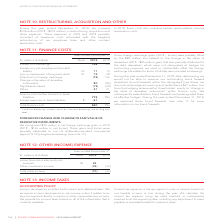According to Rogers Communications's financial document, What is included in the Interest on borrowings? Interest on borrowings includes interest on short-term borrowings and on long-term debt.. The document states: "1 Interest on borrowings includes interest on short-term borrowings and on long-term debt...." Also, What is attributed as change in fair value of derivatives? primarily attributed to the debt derivatives, which were not designated as hedges for accounting purposes, we used to substantially offset the foreign exchange risk related to these US dollar-denominated borrowings.. The document states: "of derivatives (2018 – $95 million gain) that was primarily attributed to the debt derivatives, which were not designated as hedges for accounting pur..." Also, How much was the net foreign exchange gains in 2019? $79 million in net foreign exchange gains in 2019. The document states: "FAIR VALUE OF DERIVATIVE INSTRUMENTS We recognized $79 million in net foreign exchange gains in 2019 (2018 – $136 million in net losses). These gains ..." Also, can you calculate: What is the increase/ (decrease) in Interest on borrowings from 2018 to 2019? Based on the calculation: 746-709, the result is 37 (in millions). This is based on the information: "Interest on borrowings 1 746 709 Interest on post-employment benefits liability 23 11 14 Loss on repayment of long-term debt 21 19 2 Interest on borrowings 1 746 709 Interest on post-employment benefi..." The key data points involved are: 709, 746. Also, can you calculate: What is the increase/ (decrease) in Interest on post-employment benefits liability from 2018 to 2019? Based on the calculation: 11-14, the result is -3 (in millions). This is based on the information: "Interest on post-employment benefits liability 23 11 14 Loss on repayment of long-term debt 21 19 28 (Gain) loss on foreign exchange (79) 136 Change in erest on post-employment benefits liability 23 1..." The key data points involved are: 11, 14. Also, can you calculate: What is the increase/ (decrease) in Loss on repayment of long-term debt from 2018 to 2019? Based on the calculation: 19-28, the result is -9 (in millions). This is based on the information: "3 11 14 Loss on repayment of long-term debt 21 19 28 (Gain) loss on foreign exchange (79) 136 Change in fair value of derivative instruments 80 (95) Cap y 23 11 14 Loss on repayment of long-term debt ..." The key data points involved are: 19, 28. 